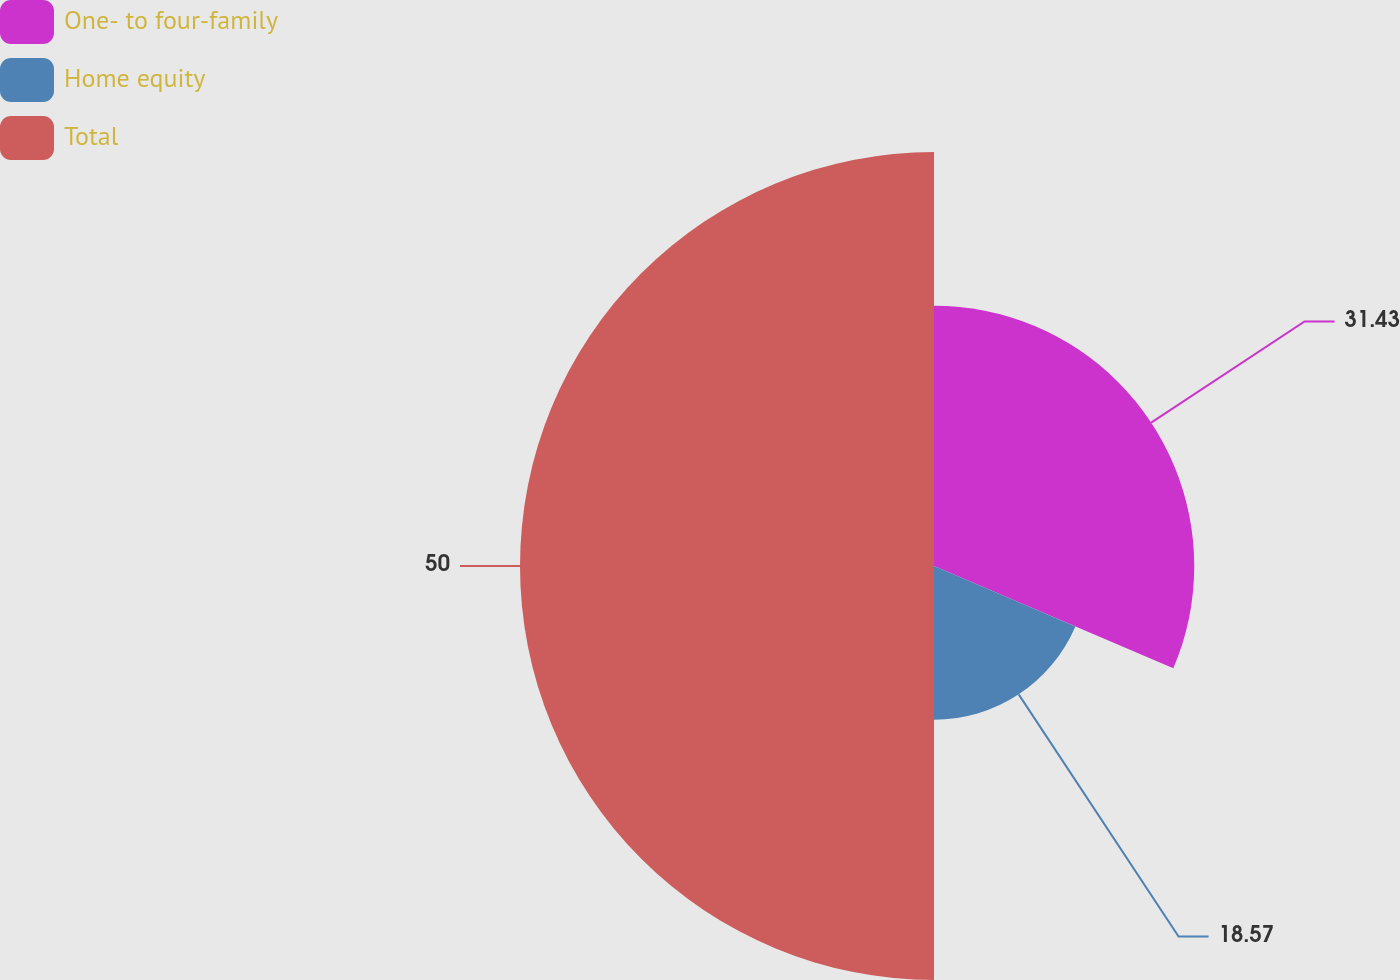Convert chart. <chart><loc_0><loc_0><loc_500><loc_500><pie_chart><fcel>One- to four-family<fcel>Home equity<fcel>Total<nl><fcel>31.43%<fcel>18.57%<fcel>50.0%<nl></chart> 